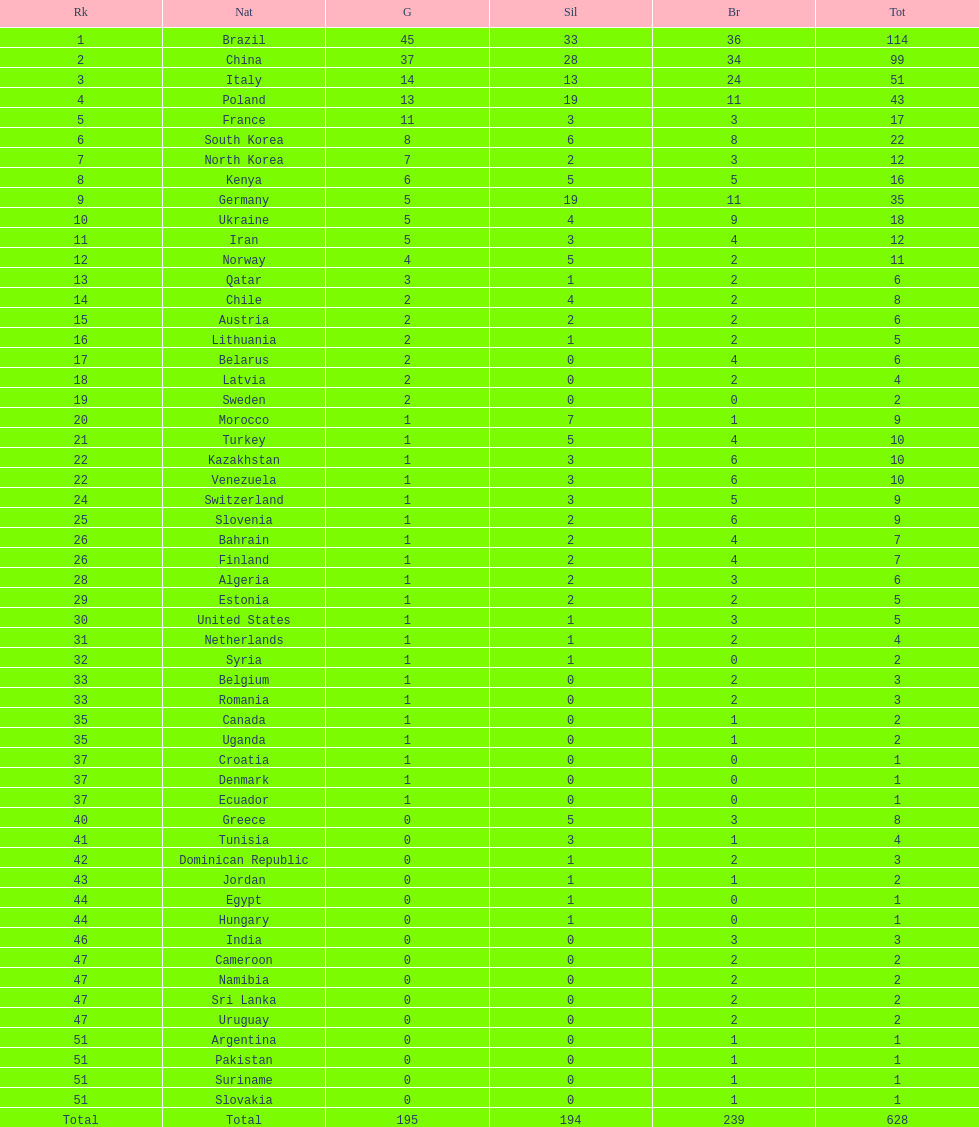How many total medals did norway win? 11. Parse the full table. {'header': ['Rk', 'Nat', 'G', 'Sil', 'Br', 'Tot'], 'rows': [['1', 'Brazil', '45', '33', '36', '114'], ['2', 'China', '37', '28', '34', '99'], ['3', 'Italy', '14', '13', '24', '51'], ['4', 'Poland', '13', '19', '11', '43'], ['5', 'France', '11', '3', '3', '17'], ['6', 'South Korea', '8', '6', '8', '22'], ['7', 'North Korea', '7', '2', '3', '12'], ['8', 'Kenya', '6', '5', '5', '16'], ['9', 'Germany', '5', '19', '11', '35'], ['10', 'Ukraine', '5', '4', '9', '18'], ['11', 'Iran', '5', '3', '4', '12'], ['12', 'Norway', '4', '5', '2', '11'], ['13', 'Qatar', '3', '1', '2', '6'], ['14', 'Chile', '2', '4', '2', '8'], ['15', 'Austria', '2', '2', '2', '6'], ['16', 'Lithuania', '2', '1', '2', '5'], ['17', 'Belarus', '2', '0', '4', '6'], ['18', 'Latvia', '2', '0', '2', '4'], ['19', 'Sweden', '2', '0', '0', '2'], ['20', 'Morocco', '1', '7', '1', '9'], ['21', 'Turkey', '1', '5', '4', '10'], ['22', 'Kazakhstan', '1', '3', '6', '10'], ['22', 'Venezuela', '1', '3', '6', '10'], ['24', 'Switzerland', '1', '3', '5', '9'], ['25', 'Slovenia', '1', '2', '6', '9'], ['26', 'Bahrain', '1', '2', '4', '7'], ['26', 'Finland', '1', '2', '4', '7'], ['28', 'Algeria', '1', '2', '3', '6'], ['29', 'Estonia', '1', '2', '2', '5'], ['30', 'United States', '1', '1', '3', '5'], ['31', 'Netherlands', '1', '1', '2', '4'], ['32', 'Syria', '1', '1', '0', '2'], ['33', 'Belgium', '1', '0', '2', '3'], ['33', 'Romania', '1', '0', '2', '3'], ['35', 'Canada', '1', '0', '1', '2'], ['35', 'Uganda', '1', '0', '1', '2'], ['37', 'Croatia', '1', '0', '0', '1'], ['37', 'Denmark', '1', '0', '0', '1'], ['37', 'Ecuador', '1', '0', '0', '1'], ['40', 'Greece', '0', '5', '3', '8'], ['41', 'Tunisia', '0', '3', '1', '4'], ['42', 'Dominican Republic', '0', '1', '2', '3'], ['43', 'Jordan', '0', '1', '1', '2'], ['44', 'Egypt', '0', '1', '0', '1'], ['44', 'Hungary', '0', '1', '0', '1'], ['46', 'India', '0', '0', '3', '3'], ['47', 'Cameroon', '0', '0', '2', '2'], ['47', 'Namibia', '0', '0', '2', '2'], ['47', 'Sri Lanka', '0', '0', '2', '2'], ['47', 'Uruguay', '0', '0', '2', '2'], ['51', 'Argentina', '0', '0', '1', '1'], ['51', 'Pakistan', '0', '0', '1', '1'], ['51', 'Suriname', '0', '0', '1', '1'], ['51', 'Slovakia', '0', '0', '1', '1'], ['Total', 'Total', '195', '194', '239', '628']]} 